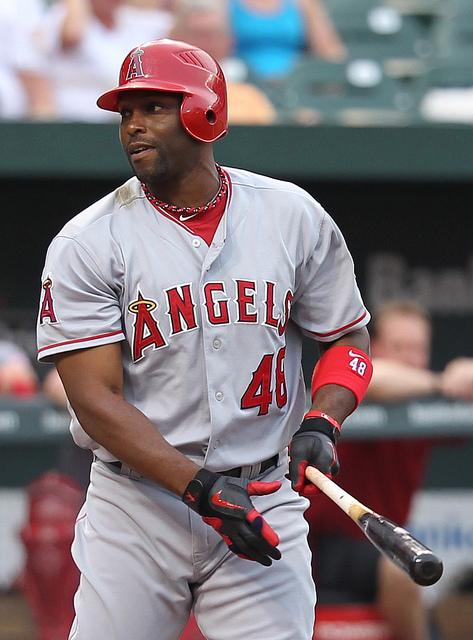Is the man wearing a hat or a helmet?
Quick response, please. Helmet. What position does this guy play?
Concise answer only. Batter. Is the man a baseball player?
Be succinct. Yes. What emotion is he feeling?
Short answer required. Happy. Who does this man play for?
Concise answer only. Angels. What is his number?
Short answer required. 48. What color are the men's gloves?
Write a very short answer. Black and red. 